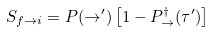<formula> <loc_0><loc_0><loc_500><loc_500>S _ { f \to i } = P ( \rightarrow ^ { \prime } ) \left [ 1 - P _ { \rightarrow } ^ { \dagger } ( \tau ^ { \prime } ) \right ]</formula> 